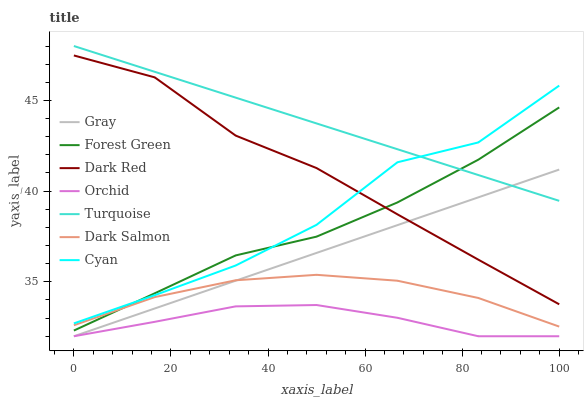Does Orchid have the minimum area under the curve?
Answer yes or no. Yes. Does Turquoise have the maximum area under the curve?
Answer yes or no. Yes. Does Dark Red have the minimum area under the curve?
Answer yes or no. No. Does Dark Red have the maximum area under the curve?
Answer yes or no. No. Is Gray the smoothest?
Answer yes or no. Yes. Is Cyan the roughest?
Answer yes or no. Yes. Is Turquoise the smoothest?
Answer yes or no. No. Is Turquoise the roughest?
Answer yes or no. No. Does Gray have the lowest value?
Answer yes or no. Yes. Does Dark Red have the lowest value?
Answer yes or no. No. Does Turquoise have the highest value?
Answer yes or no. Yes. Does Dark Red have the highest value?
Answer yes or no. No. Is Dark Salmon less than Turquoise?
Answer yes or no. Yes. Is Forest Green greater than Gray?
Answer yes or no. Yes. Does Gray intersect Dark Salmon?
Answer yes or no. Yes. Is Gray less than Dark Salmon?
Answer yes or no. No. Is Gray greater than Dark Salmon?
Answer yes or no. No. Does Dark Salmon intersect Turquoise?
Answer yes or no. No. 